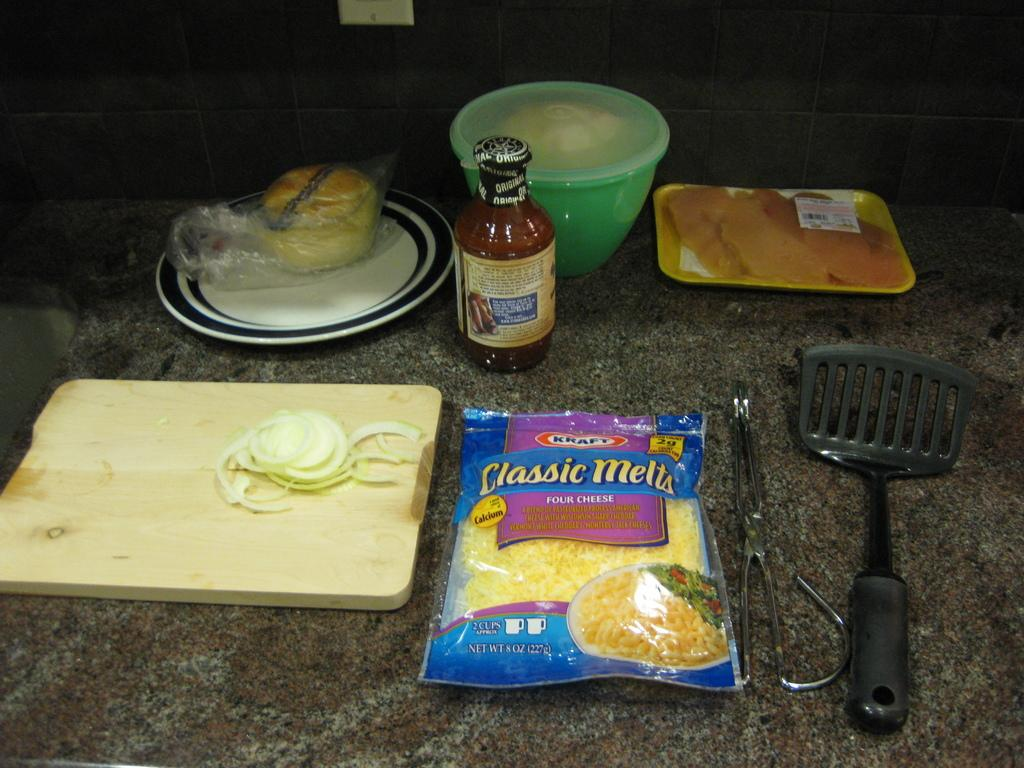What piece of furniture is present in the image? There is a table in the image. What is placed on the table? There is a bowl, a bottle, a plate, a bun, and a tray on the table. What might be used for holding or serving food in the image? The bowl, plate, and tray on the table might be used for holding or serving food. What is the purpose of the bottle on the table? The purpose of the bottle on the table is not clear from the image, but it might contain a beverage or sauce. How many cattle are grazing on the table in the image? There are no cattle present in the image; it features a table with various items on it. What type of reward is being given to the bun in the image? There is no reward being given to the bun in the image; it is simply a food item on the table. 